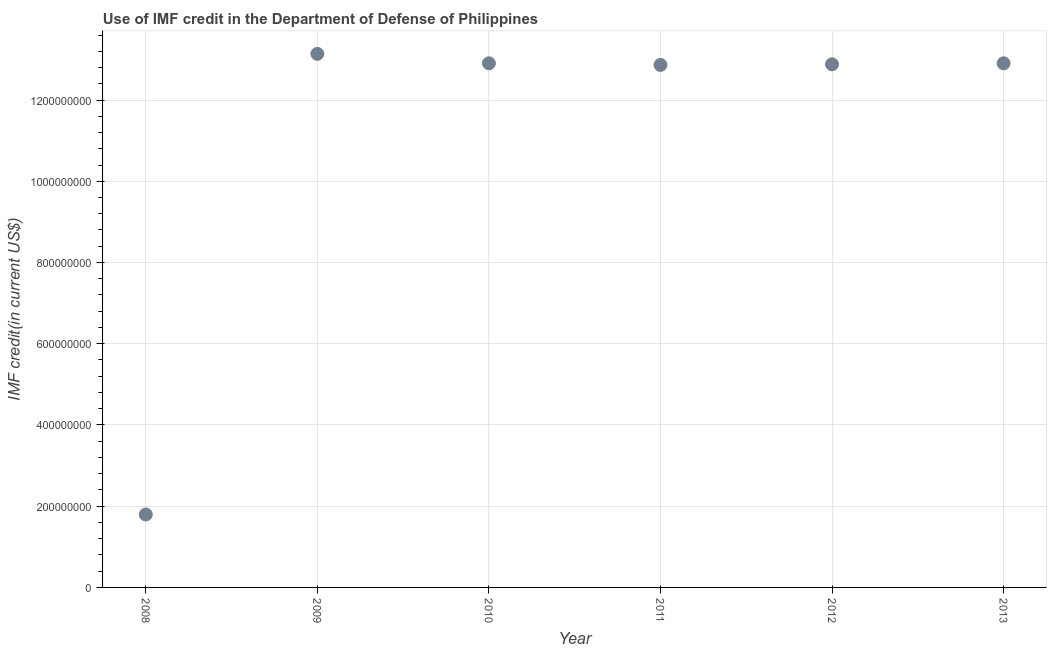What is the use of imf credit in dod in 2010?
Your answer should be compact. 1.29e+09. Across all years, what is the maximum use of imf credit in dod?
Keep it short and to the point. 1.31e+09. Across all years, what is the minimum use of imf credit in dod?
Ensure brevity in your answer.  1.80e+08. In which year was the use of imf credit in dod maximum?
Ensure brevity in your answer.  2009. What is the sum of the use of imf credit in dod?
Make the answer very short. 6.65e+09. What is the difference between the use of imf credit in dod in 2008 and 2010?
Your answer should be very brief. -1.11e+09. What is the average use of imf credit in dod per year?
Keep it short and to the point. 1.11e+09. What is the median use of imf credit in dod?
Ensure brevity in your answer.  1.29e+09. In how many years, is the use of imf credit in dod greater than 40000000 US$?
Offer a very short reply. 6. Do a majority of the years between 2013 and 2010 (inclusive) have use of imf credit in dod greater than 1120000000 US$?
Keep it short and to the point. Yes. What is the ratio of the use of imf credit in dod in 2009 to that in 2013?
Provide a succinct answer. 1.02. Is the use of imf credit in dod in 2008 less than that in 2012?
Provide a short and direct response. Yes. What is the difference between the highest and the second highest use of imf credit in dod?
Keep it short and to the point. 2.32e+07. Is the sum of the use of imf credit in dod in 2008 and 2011 greater than the maximum use of imf credit in dod across all years?
Provide a succinct answer. Yes. What is the difference between the highest and the lowest use of imf credit in dod?
Offer a terse response. 1.13e+09. In how many years, is the use of imf credit in dod greater than the average use of imf credit in dod taken over all years?
Your answer should be compact. 5. How many years are there in the graph?
Ensure brevity in your answer.  6. Does the graph contain any zero values?
Your answer should be compact. No. What is the title of the graph?
Ensure brevity in your answer.  Use of IMF credit in the Department of Defense of Philippines. What is the label or title of the X-axis?
Provide a short and direct response. Year. What is the label or title of the Y-axis?
Offer a very short reply. IMF credit(in current US$). What is the IMF credit(in current US$) in 2008?
Your answer should be very brief. 1.80e+08. What is the IMF credit(in current US$) in 2009?
Your answer should be compact. 1.31e+09. What is the IMF credit(in current US$) in 2010?
Keep it short and to the point. 1.29e+09. What is the IMF credit(in current US$) in 2011?
Your response must be concise. 1.29e+09. What is the IMF credit(in current US$) in 2012?
Your answer should be compact. 1.29e+09. What is the IMF credit(in current US$) in 2013?
Your answer should be very brief. 1.29e+09. What is the difference between the IMF credit(in current US$) in 2008 and 2009?
Provide a succinct answer. -1.13e+09. What is the difference between the IMF credit(in current US$) in 2008 and 2010?
Give a very brief answer. -1.11e+09. What is the difference between the IMF credit(in current US$) in 2008 and 2011?
Offer a very short reply. -1.11e+09. What is the difference between the IMF credit(in current US$) in 2008 and 2012?
Ensure brevity in your answer.  -1.11e+09. What is the difference between the IMF credit(in current US$) in 2008 and 2013?
Offer a terse response. -1.11e+09. What is the difference between the IMF credit(in current US$) in 2009 and 2010?
Your answer should be very brief. 2.32e+07. What is the difference between the IMF credit(in current US$) in 2009 and 2011?
Your answer should be very brief. 2.72e+07. What is the difference between the IMF credit(in current US$) in 2009 and 2012?
Keep it short and to the point. 2.58e+07. What is the difference between the IMF credit(in current US$) in 2009 and 2013?
Give a very brief answer. 2.32e+07. What is the difference between the IMF credit(in current US$) in 2010 and 2011?
Ensure brevity in your answer.  3.99e+06. What is the difference between the IMF credit(in current US$) in 2010 and 2012?
Keep it short and to the point. 2.61e+06. What is the difference between the IMF credit(in current US$) in 2010 and 2013?
Keep it short and to the point. 2.50e+04. What is the difference between the IMF credit(in current US$) in 2011 and 2012?
Ensure brevity in your answer.  -1.38e+06. What is the difference between the IMF credit(in current US$) in 2011 and 2013?
Ensure brevity in your answer.  -3.96e+06. What is the difference between the IMF credit(in current US$) in 2012 and 2013?
Your answer should be compact. -2.58e+06. What is the ratio of the IMF credit(in current US$) in 2008 to that in 2009?
Your response must be concise. 0.14. What is the ratio of the IMF credit(in current US$) in 2008 to that in 2010?
Offer a very short reply. 0.14. What is the ratio of the IMF credit(in current US$) in 2008 to that in 2011?
Your answer should be very brief. 0.14. What is the ratio of the IMF credit(in current US$) in 2008 to that in 2012?
Your answer should be compact. 0.14. What is the ratio of the IMF credit(in current US$) in 2008 to that in 2013?
Your answer should be compact. 0.14. What is the ratio of the IMF credit(in current US$) in 2010 to that in 2011?
Your response must be concise. 1. What is the ratio of the IMF credit(in current US$) in 2012 to that in 2013?
Make the answer very short. 1. 